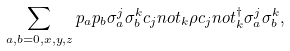<formula> <loc_0><loc_0><loc_500><loc_500>\sum _ { a , b = 0 , x , y , z } p _ { a } p _ { b } \sigma _ { a } ^ { j } \sigma _ { b } ^ { k } c _ { j } n o t _ { k } \rho c _ { j } n o t _ { k } ^ { \dag } \sigma _ { a } ^ { j } \sigma _ { b } ^ { k } ,</formula> 